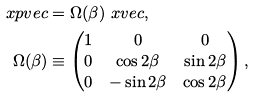<formula> <loc_0><loc_0><loc_500><loc_500>\ x p v e c & = \Omega ( \beta ) \ x v e c , \\ \Omega ( \beta ) & \equiv \begin{pmatrix} 1 & 0 & 0 \\ 0 & \cos 2 \beta & \sin 2 \beta \\ 0 & - \sin 2 \beta & \cos 2 \beta \end{pmatrix} ,</formula> 